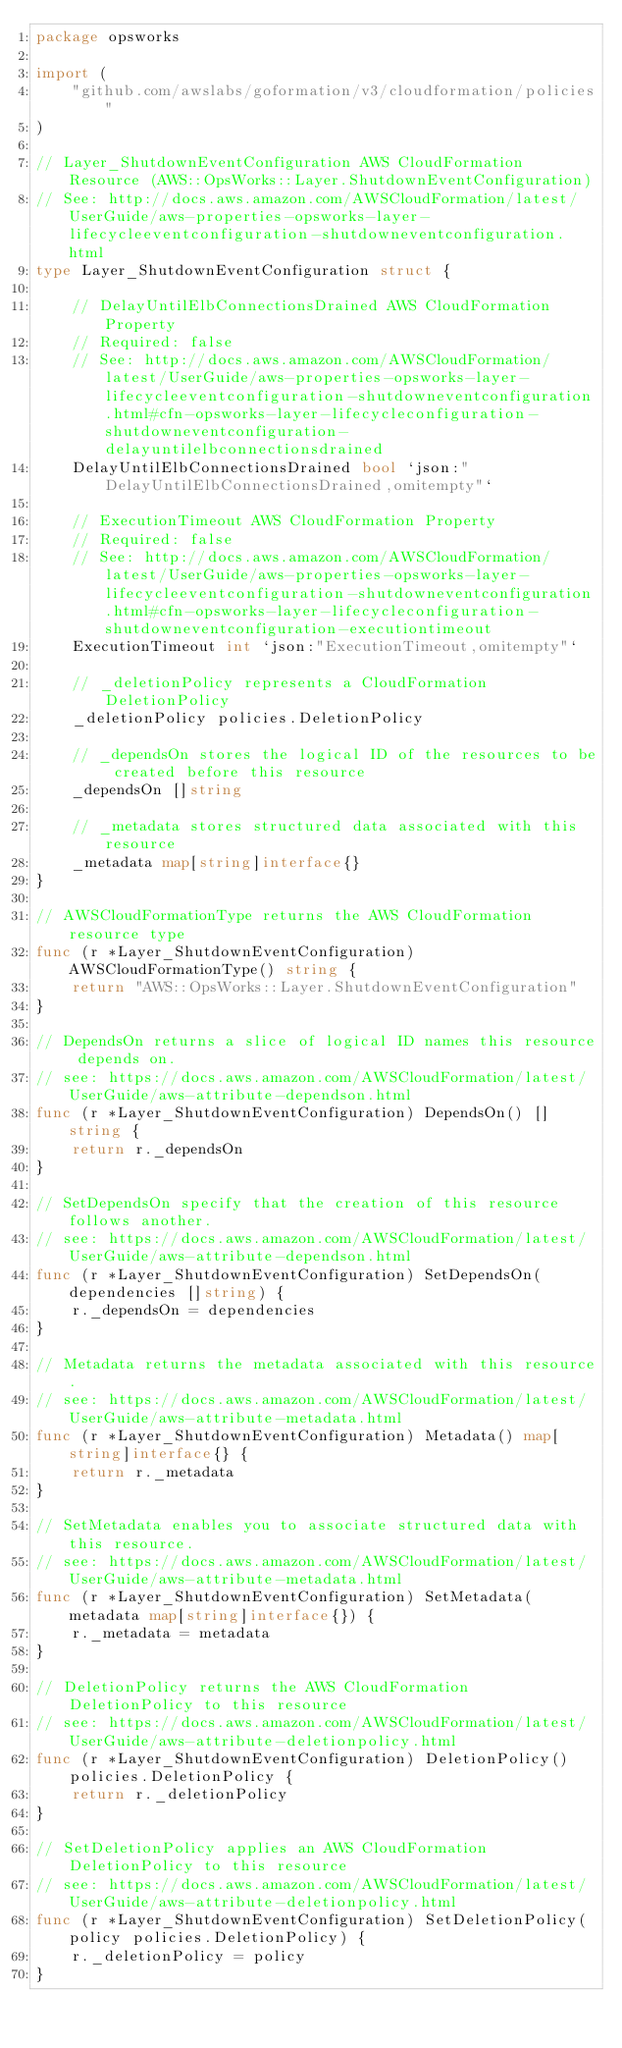<code> <loc_0><loc_0><loc_500><loc_500><_Go_>package opsworks

import (
	"github.com/awslabs/goformation/v3/cloudformation/policies"
)

// Layer_ShutdownEventConfiguration AWS CloudFormation Resource (AWS::OpsWorks::Layer.ShutdownEventConfiguration)
// See: http://docs.aws.amazon.com/AWSCloudFormation/latest/UserGuide/aws-properties-opsworks-layer-lifecycleeventconfiguration-shutdowneventconfiguration.html
type Layer_ShutdownEventConfiguration struct {

	// DelayUntilElbConnectionsDrained AWS CloudFormation Property
	// Required: false
	// See: http://docs.aws.amazon.com/AWSCloudFormation/latest/UserGuide/aws-properties-opsworks-layer-lifecycleeventconfiguration-shutdowneventconfiguration.html#cfn-opsworks-layer-lifecycleconfiguration-shutdowneventconfiguration-delayuntilelbconnectionsdrained
	DelayUntilElbConnectionsDrained bool `json:"DelayUntilElbConnectionsDrained,omitempty"`

	// ExecutionTimeout AWS CloudFormation Property
	// Required: false
	// See: http://docs.aws.amazon.com/AWSCloudFormation/latest/UserGuide/aws-properties-opsworks-layer-lifecycleeventconfiguration-shutdowneventconfiguration.html#cfn-opsworks-layer-lifecycleconfiguration-shutdowneventconfiguration-executiontimeout
	ExecutionTimeout int `json:"ExecutionTimeout,omitempty"`

	// _deletionPolicy represents a CloudFormation DeletionPolicy
	_deletionPolicy policies.DeletionPolicy

	// _dependsOn stores the logical ID of the resources to be created before this resource
	_dependsOn []string

	// _metadata stores structured data associated with this resource
	_metadata map[string]interface{}
}

// AWSCloudFormationType returns the AWS CloudFormation resource type
func (r *Layer_ShutdownEventConfiguration) AWSCloudFormationType() string {
	return "AWS::OpsWorks::Layer.ShutdownEventConfiguration"
}

// DependsOn returns a slice of logical ID names this resource depends on.
// see: https://docs.aws.amazon.com/AWSCloudFormation/latest/UserGuide/aws-attribute-dependson.html
func (r *Layer_ShutdownEventConfiguration) DependsOn() []string {
	return r._dependsOn
}

// SetDependsOn specify that the creation of this resource follows another.
// see: https://docs.aws.amazon.com/AWSCloudFormation/latest/UserGuide/aws-attribute-dependson.html
func (r *Layer_ShutdownEventConfiguration) SetDependsOn(dependencies []string) {
	r._dependsOn = dependencies
}

// Metadata returns the metadata associated with this resource.
// see: https://docs.aws.amazon.com/AWSCloudFormation/latest/UserGuide/aws-attribute-metadata.html
func (r *Layer_ShutdownEventConfiguration) Metadata() map[string]interface{} {
	return r._metadata
}

// SetMetadata enables you to associate structured data with this resource.
// see: https://docs.aws.amazon.com/AWSCloudFormation/latest/UserGuide/aws-attribute-metadata.html
func (r *Layer_ShutdownEventConfiguration) SetMetadata(metadata map[string]interface{}) {
	r._metadata = metadata
}

// DeletionPolicy returns the AWS CloudFormation DeletionPolicy to this resource
// see: https://docs.aws.amazon.com/AWSCloudFormation/latest/UserGuide/aws-attribute-deletionpolicy.html
func (r *Layer_ShutdownEventConfiguration) DeletionPolicy() policies.DeletionPolicy {
	return r._deletionPolicy
}

// SetDeletionPolicy applies an AWS CloudFormation DeletionPolicy to this resource
// see: https://docs.aws.amazon.com/AWSCloudFormation/latest/UserGuide/aws-attribute-deletionpolicy.html
func (r *Layer_ShutdownEventConfiguration) SetDeletionPolicy(policy policies.DeletionPolicy) {
	r._deletionPolicy = policy
}
</code> 